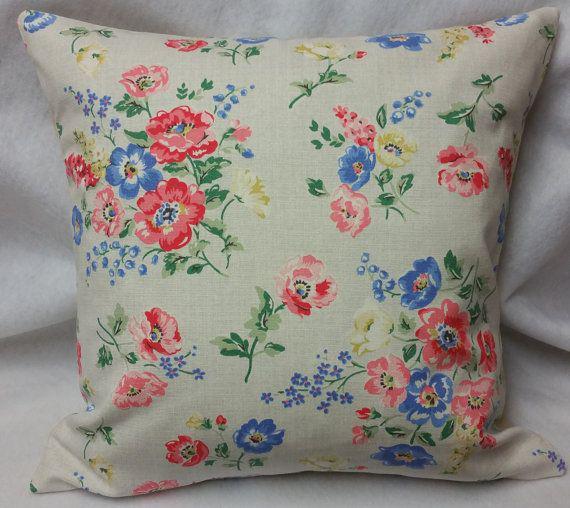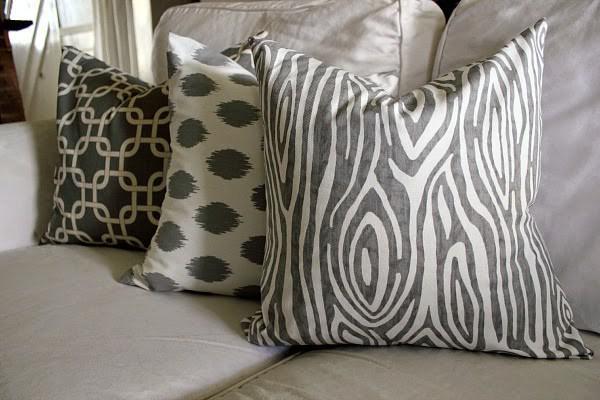The first image is the image on the left, the second image is the image on the right. For the images shown, is this caption "There are more pillows in the left image than in the right image." true? Answer yes or no. No. The first image is the image on the left, the second image is the image on the right. For the images displayed, is the sentence "There are there different pillows sitting in a row on top of a cream colored sofa." factually correct? Answer yes or no. Yes. 